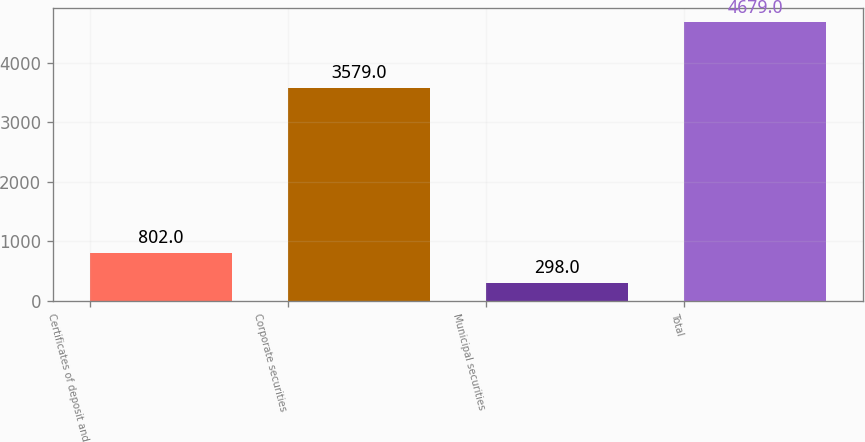<chart> <loc_0><loc_0><loc_500><loc_500><bar_chart><fcel>Certificates of deposit and<fcel>Corporate securities<fcel>Municipal securities<fcel>Total<nl><fcel>802<fcel>3579<fcel>298<fcel>4679<nl></chart> 